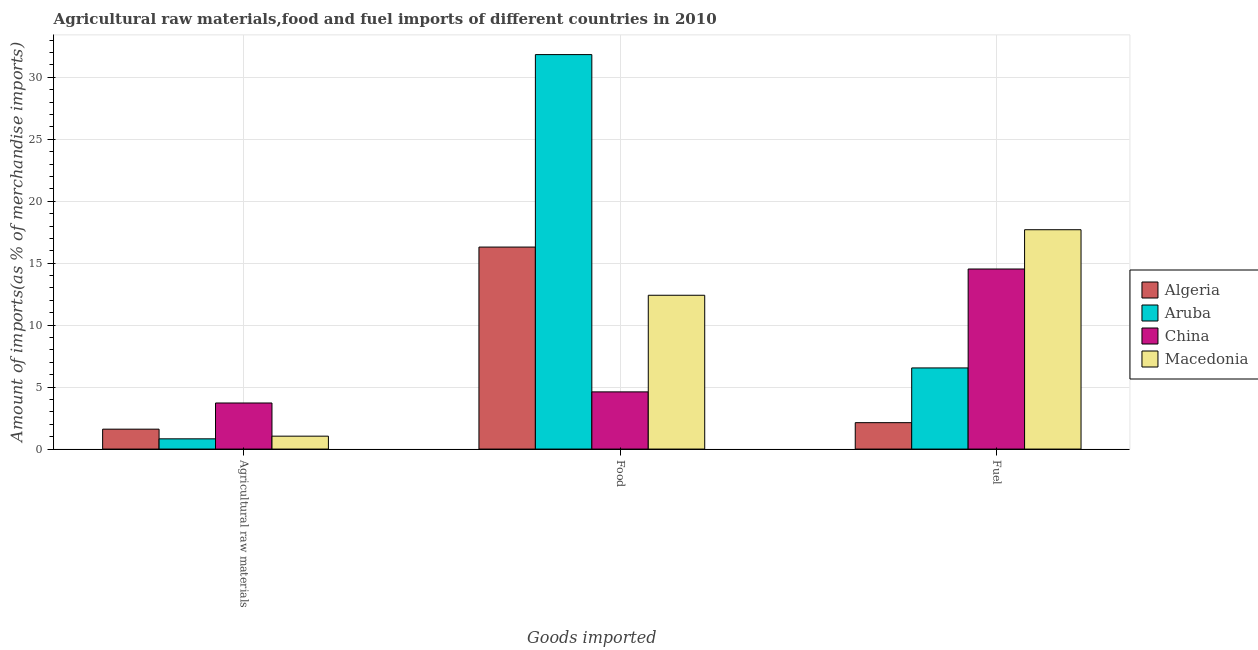Are the number of bars per tick equal to the number of legend labels?
Offer a terse response. Yes. Are the number of bars on each tick of the X-axis equal?
Provide a succinct answer. Yes. How many bars are there on the 3rd tick from the left?
Your answer should be compact. 4. How many bars are there on the 2nd tick from the right?
Keep it short and to the point. 4. What is the label of the 3rd group of bars from the left?
Keep it short and to the point. Fuel. What is the percentage of raw materials imports in Algeria?
Provide a short and direct response. 1.61. Across all countries, what is the maximum percentage of raw materials imports?
Your answer should be compact. 3.72. Across all countries, what is the minimum percentage of fuel imports?
Provide a short and direct response. 2.13. In which country was the percentage of fuel imports maximum?
Make the answer very short. Macedonia. In which country was the percentage of fuel imports minimum?
Your answer should be very brief. Algeria. What is the total percentage of raw materials imports in the graph?
Give a very brief answer. 7.19. What is the difference between the percentage of food imports in China and that in Algeria?
Ensure brevity in your answer.  -11.69. What is the difference between the percentage of fuel imports in Algeria and the percentage of raw materials imports in Aruba?
Keep it short and to the point. 1.31. What is the average percentage of fuel imports per country?
Make the answer very short. 10.23. What is the difference between the percentage of raw materials imports and percentage of food imports in China?
Provide a short and direct response. -0.9. What is the ratio of the percentage of fuel imports in Algeria to that in Macedonia?
Provide a short and direct response. 0.12. Is the difference between the percentage of food imports in Aruba and Algeria greater than the difference between the percentage of raw materials imports in Aruba and Algeria?
Your answer should be compact. Yes. What is the difference between the highest and the second highest percentage of food imports?
Make the answer very short. 15.53. What is the difference between the highest and the lowest percentage of raw materials imports?
Provide a short and direct response. 2.89. What does the 3rd bar from the left in Fuel represents?
Your answer should be compact. China. How many bars are there?
Make the answer very short. 12. Are all the bars in the graph horizontal?
Offer a very short reply. No. What is the difference between two consecutive major ticks on the Y-axis?
Your answer should be very brief. 5. Does the graph contain any zero values?
Offer a very short reply. No. Where does the legend appear in the graph?
Give a very brief answer. Center right. How are the legend labels stacked?
Your answer should be very brief. Vertical. What is the title of the graph?
Ensure brevity in your answer.  Agricultural raw materials,food and fuel imports of different countries in 2010. Does "Finland" appear as one of the legend labels in the graph?
Keep it short and to the point. No. What is the label or title of the X-axis?
Give a very brief answer. Goods imported. What is the label or title of the Y-axis?
Make the answer very short. Amount of imports(as % of merchandise imports). What is the Amount of imports(as % of merchandise imports) of Algeria in Agricultural raw materials?
Offer a very short reply. 1.61. What is the Amount of imports(as % of merchandise imports) in Aruba in Agricultural raw materials?
Your answer should be very brief. 0.83. What is the Amount of imports(as % of merchandise imports) in China in Agricultural raw materials?
Provide a short and direct response. 3.72. What is the Amount of imports(as % of merchandise imports) in Macedonia in Agricultural raw materials?
Offer a very short reply. 1.04. What is the Amount of imports(as % of merchandise imports) of Algeria in Food?
Offer a terse response. 16.3. What is the Amount of imports(as % of merchandise imports) of Aruba in Food?
Your answer should be very brief. 31.83. What is the Amount of imports(as % of merchandise imports) of China in Food?
Make the answer very short. 4.62. What is the Amount of imports(as % of merchandise imports) of Macedonia in Food?
Keep it short and to the point. 12.41. What is the Amount of imports(as % of merchandise imports) in Algeria in Fuel?
Your answer should be compact. 2.13. What is the Amount of imports(as % of merchandise imports) of Aruba in Fuel?
Give a very brief answer. 6.55. What is the Amount of imports(as % of merchandise imports) of China in Fuel?
Your response must be concise. 14.53. What is the Amount of imports(as % of merchandise imports) of Macedonia in Fuel?
Offer a very short reply. 17.7. Across all Goods imported, what is the maximum Amount of imports(as % of merchandise imports) in Algeria?
Your answer should be compact. 16.3. Across all Goods imported, what is the maximum Amount of imports(as % of merchandise imports) of Aruba?
Provide a short and direct response. 31.83. Across all Goods imported, what is the maximum Amount of imports(as % of merchandise imports) of China?
Ensure brevity in your answer.  14.53. Across all Goods imported, what is the maximum Amount of imports(as % of merchandise imports) of Macedonia?
Offer a terse response. 17.7. Across all Goods imported, what is the minimum Amount of imports(as % of merchandise imports) of Algeria?
Make the answer very short. 1.61. Across all Goods imported, what is the minimum Amount of imports(as % of merchandise imports) of Aruba?
Your answer should be compact. 0.83. Across all Goods imported, what is the minimum Amount of imports(as % of merchandise imports) of China?
Provide a succinct answer. 3.72. Across all Goods imported, what is the minimum Amount of imports(as % of merchandise imports) of Macedonia?
Give a very brief answer. 1.04. What is the total Amount of imports(as % of merchandise imports) in Algeria in the graph?
Your answer should be very brief. 20.04. What is the total Amount of imports(as % of merchandise imports) of Aruba in the graph?
Make the answer very short. 39.21. What is the total Amount of imports(as % of merchandise imports) in China in the graph?
Your response must be concise. 22.86. What is the total Amount of imports(as % of merchandise imports) of Macedonia in the graph?
Offer a very short reply. 31.15. What is the difference between the Amount of imports(as % of merchandise imports) of Algeria in Agricultural raw materials and that in Food?
Ensure brevity in your answer.  -14.69. What is the difference between the Amount of imports(as % of merchandise imports) in Aruba in Agricultural raw materials and that in Food?
Provide a short and direct response. -31.01. What is the difference between the Amount of imports(as % of merchandise imports) in China in Agricultural raw materials and that in Food?
Offer a very short reply. -0.9. What is the difference between the Amount of imports(as % of merchandise imports) of Macedonia in Agricultural raw materials and that in Food?
Give a very brief answer. -11.37. What is the difference between the Amount of imports(as % of merchandise imports) of Algeria in Agricultural raw materials and that in Fuel?
Give a very brief answer. -0.52. What is the difference between the Amount of imports(as % of merchandise imports) in Aruba in Agricultural raw materials and that in Fuel?
Your answer should be compact. -5.72. What is the difference between the Amount of imports(as % of merchandise imports) of China in Agricultural raw materials and that in Fuel?
Your answer should be very brief. -10.81. What is the difference between the Amount of imports(as % of merchandise imports) of Macedonia in Agricultural raw materials and that in Fuel?
Provide a succinct answer. -16.66. What is the difference between the Amount of imports(as % of merchandise imports) of Algeria in Food and that in Fuel?
Ensure brevity in your answer.  14.17. What is the difference between the Amount of imports(as % of merchandise imports) of Aruba in Food and that in Fuel?
Keep it short and to the point. 25.28. What is the difference between the Amount of imports(as % of merchandise imports) of China in Food and that in Fuel?
Your answer should be very brief. -9.92. What is the difference between the Amount of imports(as % of merchandise imports) in Macedonia in Food and that in Fuel?
Your answer should be very brief. -5.29. What is the difference between the Amount of imports(as % of merchandise imports) in Algeria in Agricultural raw materials and the Amount of imports(as % of merchandise imports) in Aruba in Food?
Your response must be concise. -30.22. What is the difference between the Amount of imports(as % of merchandise imports) in Algeria in Agricultural raw materials and the Amount of imports(as % of merchandise imports) in China in Food?
Offer a very short reply. -3.01. What is the difference between the Amount of imports(as % of merchandise imports) of Algeria in Agricultural raw materials and the Amount of imports(as % of merchandise imports) of Macedonia in Food?
Provide a succinct answer. -10.81. What is the difference between the Amount of imports(as % of merchandise imports) of Aruba in Agricultural raw materials and the Amount of imports(as % of merchandise imports) of China in Food?
Provide a succinct answer. -3.79. What is the difference between the Amount of imports(as % of merchandise imports) of Aruba in Agricultural raw materials and the Amount of imports(as % of merchandise imports) of Macedonia in Food?
Keep it short and to the point. -11.59. What is the difference between the Amount of imports(as % of merchandise imports) in China in Agricultural raw materials and the Amount of imports(as % of merchandise imports) in Macedonia in Food?
Provide a short and direct response. -8.69. What is the difference between the Amount of imports(as % of merchandise imports) in Algeria in Agricultural raw materials and the Amount of imports(as % of merchandise imports) in Aruba in Fuel?
Provide a short and direct response. -4.94. What is the difference between the Amount of imports(as % of merchandise imports) of Algeria in Agricultural raw materials and the Amount of imports(as % of merchandise imports) of China in Fuel?
Your response must be concise. -12.92. What is the difference between the Amount of imports(as % of merchandise imports) in Algeria in Agricultural raw materials and the Amount of imports(as % of merchandise imports) in Macedonia in Fuel?
Keep it short and to the point. -16.09. What is the difference between the Amount of imports(as % of merchandise imports) in Aruba in Agricultural raw materials and the Amount of imports(as % of merchandise imports) in China in Fuel?
Your answer should be compact. -13.7. What is the difference between the Amount of imports(as % of merchandise imports) of Aruba in Agricultural raw materials and the Amount of imports(as % of merchandise imports) of Macedonia in Fuel?
Give a very brief answer. -16.87. What is the difference between the Amount of imports(as % of merchandise imports) of China in Agricultural raw materials and the Amount of imports(as % of merchandise imports) of Macedonia in Fuel?
Ensure brevity in your answer.  -13.98. What is the difference between the Amount of imports(as % of merchandise imports) in Algeria in Food and the Amount of imports(as % of merchandise imports) in Aruba in Fuel?
Offer a very short reply. 9.75. What is the difference between the Amount of imports(as % of merchandise imports) of Algeria in Food and the Amount of imports(as % of merchandise imports) of China in Fuel?
Offer a terse response. 1.77. What is the difference between the Amount of imports(as % of merchandise imports) in Algeria in Food and the Amount of imports(as % of merchandise imports) in Macedonia in Fuel?
Ensure brevity in your answer.  -1.4. What is the difference between the Amount of imports(as % of merchandise imports) in Aruba in Food and the Amount of imports(as % of merchandise imports) in China in Fuel?
Offer a terse response. 17.3. What is the difference between the Amount of imports(as % of merchandise imports) in Aruba in Food and the Amount of imports(as % of merchandise imports) in Macedonia in Fuel?
Provide a succinct answer. 14.13. What is the difference between the Amount of imports(as % of merchandise imports) in China in Food and the Amount of imports(as % of merchandise imports) in Macedonia in Fuel?
Ensure brevity in your answer.  -13.08. What is the average Amount of imports(as % of merchandise imports) of Algeria per Goods imported?
Provide a short and direct response. 6.68. What is the average Amount of imports(as % of merchandise imports) in Aruba per Goods imported?
Your response must be concise. 13.07. What is the average Amount of imports(as % of merchandise imports) in China per Goods imported?
Ensure brevity in your answer.  7.62. What is the average Amount of imports(as % of merchandise imports) of Macedonia per Goods imported?
Your answer should be very brief. 10.38. What is the difference between the Amount of imports(as % of merchandise imports) of Algeria and Amount of imports(as % of merchandise imports) of Aruba in Agricultural raw materials?
Provide a short and direct response. 0.78. What is the difference between the Amount of imports(as % of merchandise imports) in Algeria and Amount of imports(as % of merchandise imports) in China in Agricultural raw materials?
Give a very brief answer. -2.11. What is the difference between the Amount of imports(as % of merchandise imports) of Algeria and Amount of imports(as % of merchandise imports) of Macedonia in Agricultural raw materials?
Your answer should be very brief. 0.57. What is the difference between the Amount of imports(as % of merchandise imports) in Aruba and Amount of imports(as % of merchandise imports) in China in Agricultural raw materials?
Give a very brief answer. -2.89. What is the difference between the Amount of imports(as % of merchandise imports) of Aruba and Amount of imports(as % of merchandise imports) of Macedonia in Agricultural raw materials?
Ensure brevity in your answer.  -0.22. What is the difference between the Amount of imports(as % of merchandise imports) in China and Amount of imports(as % of merchandise imports) in Macedonia in Agricultural raw materials?
Offer a terse response. 2.68. What is the difference between the Amount of imports(as % of merchandise imports) of Algeria and Amount of imports(as % of merchandise imports) of Aruba in Food?
Your response must be concise. -15.53. What is the difference between the Amount of imports(as % of merchandise imports) in Algeria and Amount of imports(as % of merchandise imports) in China in Food?
Offer a very short reply. 11.69. What is the difference between the Amount of imports(as % of merchandise imports) of Algeria and Amount of imports(as % of merchandise imports) of Macedonia in Food?
Ensure brevity in your answer.  3.89. What is the difference between the Amount of imports(as % of merchandise imports) in Aruba and Amount of imports(as % of merchandise imports) in China in Food?
Offer a terse response. 27.22. What is the difference between the Amount of imports(as % of merchandise imports) of Aruba and Amount of imports(as % of merchandise imports) of Macedonia in Food?
Make the answer very short. 19.42. What is the difference between the Amount of imports(as % of merchandise imports) of China and Amount of imports(as % of merchandise imports) of Macedonia in Food?
Your response must be concise. -7.8. What is the difference between the Amount of imports(as % of merchandise imports) in Algeria and Amount of imports(as % of merchandise imports) in Aruba in Fuel?
Offer a very short reply. -4.42. What is the difference between the Amount of imports(as % of merchandise imports) in Algeria and Amount of imports(as % of merchandise imports) in China in Fuel?
Offer a terse response. -12.4. What is the difference between the Amount of imports(as % of merchandise imports) of Algeria and Amount of imports(as % of merchandise imports) of Macedonia in Fuel?
Offer a terse response. -15.57. What is the difference between the Amount of imports(as % of merchandise imports) in Aruba and Amount of imports(as % of merchandise imports) in China in Fuel?
Keep it short and to the point. -7.98. What is the difference between the Amount of imports(as % of merchandise imports) in Aruba and Amount of imports(as % of merchandise imports) in Macedonia in Fuel?
Make the answer very short. -11.15. What is the difference between the Amount of imports(as % of merchandise imports) of China and Amount of imports(as % of merchandise imports) of Macedonia in Fuel?
Your answer should be compact. -3.17. What is the ratio of the Amount of imports(as % of merchandise imports) in Algeria in Agricultural raw materials to that in Food?
Your answer should be very brief. 0.1. What is the ratio of the Amount of imports(as % of merchandise imports) of Aruba in Agricultural raw materials to that in Food?
Provide a succinct answer. 0.03. What is the ratio of the Amount of imports(as % of merchandise imports) in China in Agricultural raw materials to that in Food?
Ensure brevity in your answer.  0.81. What is the ratio of the Amount of imports(as % of merchandise imports) of Macedonia in Agricultural raw materials to that in Food?
Provide a succinct answer. 0.08. What is the ratio of the Amount of imports(as % of merchandise imports) in Algeria in Agricultural raw materials to that in Fuel?
Offer a very short reply. 0.75. What is the ratio of the Amount of imports(as % of merchandise imports) of Aruba in Agricultural raw materials to that in Fuel?
Give a very brief answer. 0.13. What is the ratio of the Amount of imports(as % of merchandise imports) of China in Agricultural raw materials to that in Fuel?
Give a very brief answer. 0.26. What is the ratio of the Amount of imports(as % of merchandise imports) of Macedonia in Agricultural raw materials to that in Fuel?
Make the answer very short. 0.06. What is the ratio of the Amount of imports(as % of merchandise imports) of Algeria in Food to that in Fuel?
Give a very brief answer. 7.65. What is the ratio of the Amount of imports(as % of merchandise imports) in Aruba in Food to that in Fuel?
Keep it short and to the point. 4.86. What is the ratio of the Amount of imports(as % of merchandise imports) of China in Food to that in Fuel?
Offer a terse response. 0.32. What is the ratio of the Amount of imports(as % of merchandise imports) in Macedonia in Food to that in Fuel?
Your response must be concise. 0.7. What is the difference between the highest and the second highest Amount of imports(as % of merchandise imports) in Algeria?
Ensure brevity in your answer.  14.17. What is the difference between the highest and the second highest Amount of imports(as % of merchandise imports) in Aruba?
Give a very brief answer. 25.28. What is the difference between the highest and the second highest Amount of imports(as % of merchandise imports) in China?
Provide a short and direct response. 9.92. What is the difference between the highest and the second highest Amount of imports(as % of merchandise imports) of Macedonia?
Make the answer very short. 5.29. What is the difference between the highest and the lowest Amount of imports(as % of merchandise imports) of Algeria?
Your response must be concise. 14.69. What is the difference between the highest and the lowest Amount of imports(as % of merchandise imports) of Aruba?
Ensure brevity in your answer.  31.01. What is the difference between the highest and the lowest Amount of imports(as % of merchandise imports) in China?
Your answer should be compact. 10.81. What is the difference between the highest and the lowest Amount of imports(as % of merchandise imports) of Macedonia?
Provide a short and direct response. 16.66. 